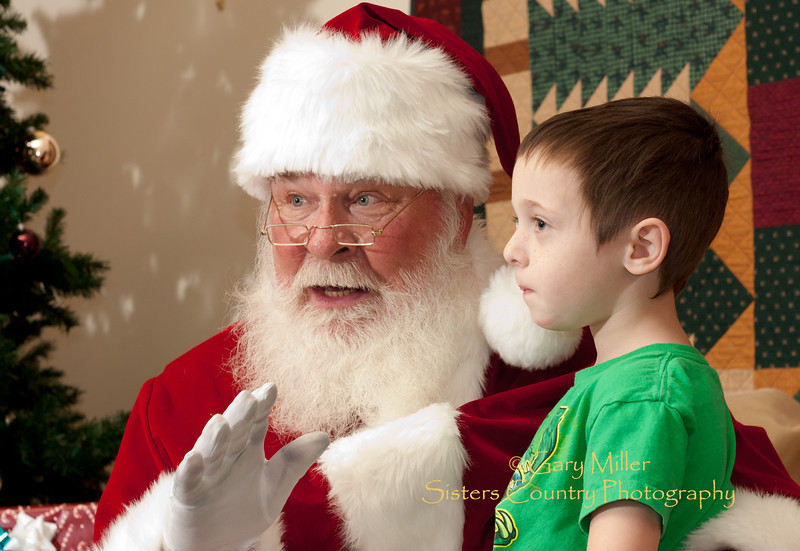What can be inferred about the child's reaction to the person dressed as Santa Claus based on his body language and expression? From the child's body language and expression in the image, it appears he is exhibiting a sense of calm attentiveness. He appears carefully engaged with Santa, likely absorbed by the story or conversation unfolding. His body, turned towards Santa with eyes fixed intently, suggests a keen interest and respect for the figure before him. This thoughtful demeanor indicates a mixture of reverence and curiosity, commonly seen in children during such captivating moments. 